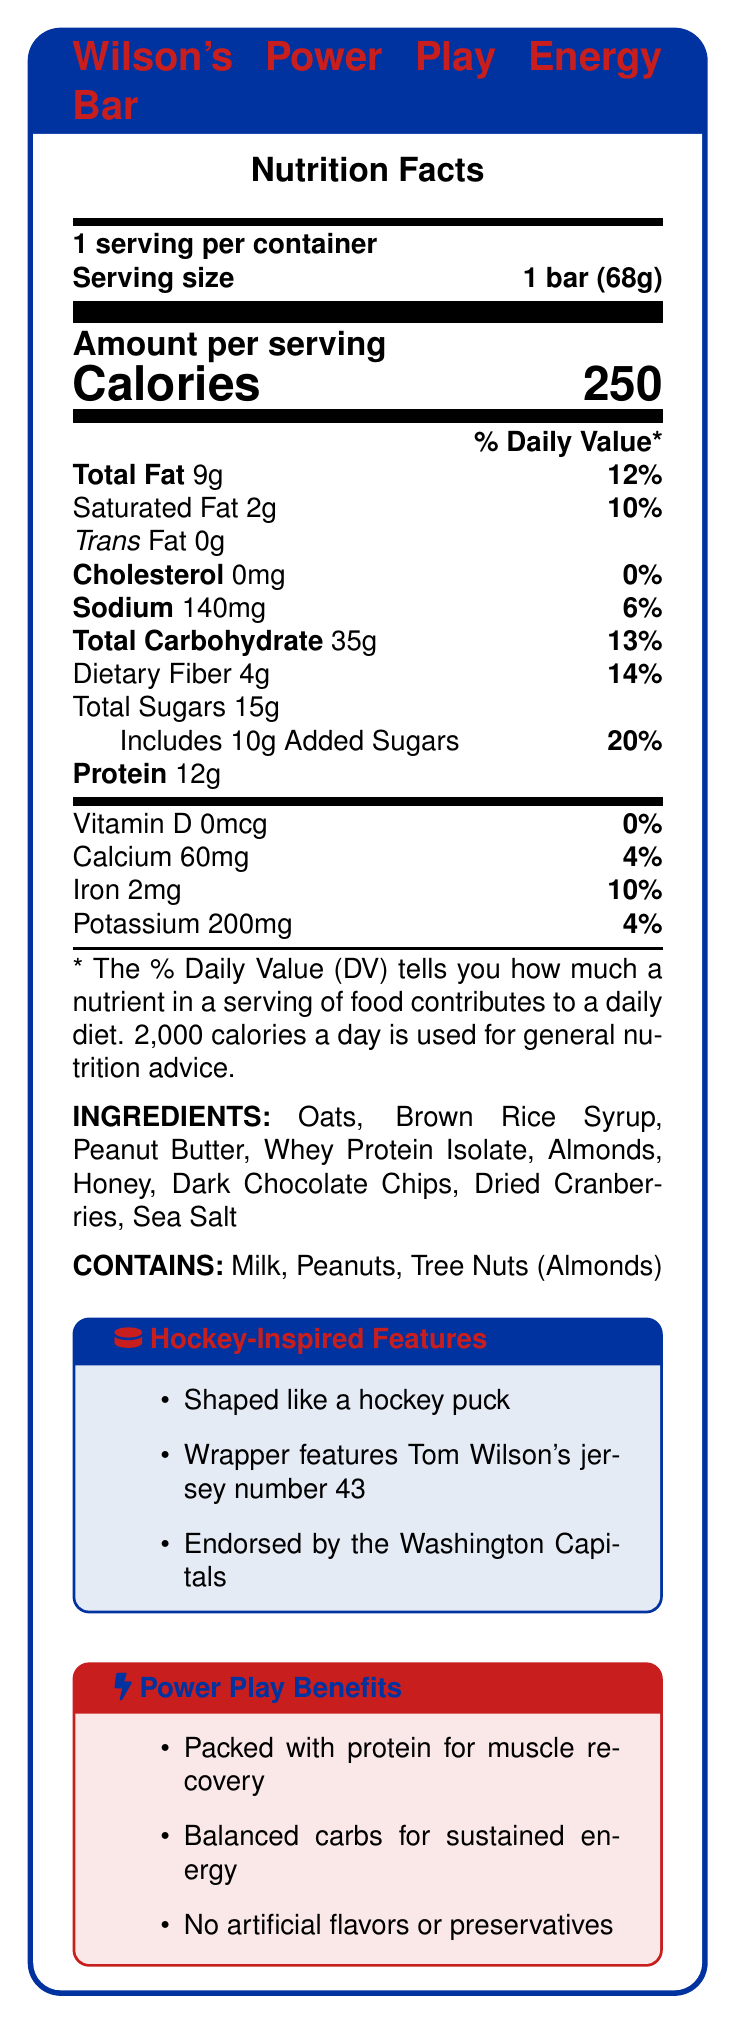What is the serving size of Wilson's Power Play Energy Bar? The document specifies that the serving size for Wilson's Power Play Energy Bar is 1 bar (68g).
Answer: 1 bar (68g) What is the amount of added sugars in the energy bar? According to the Nutrition Facts, the energy bar contains 10g of added sugars.
Answer: 10g How much protein does the bar contain? The document states that there is 12g of protein per serving in the energy bar.
Answer: 12g Which vitamin is completely absent in Wilson's Power Play Energy Bar? The label shows that there is 0mcg of Vitamin D, which means it is absent.
Answer: Vitamin D What are the main ingredients in Wilson's Power Play Energy Bar? The ingredients listed on the document are the main components of the energy bar.
Answer: Oats, Brown Rice Syrup, Peanut Butter, Whey Protein Isolate, Almonds, Honey, Dark Chocolate Chips, Dried Cranberries, Sea Salt How much is the daily value percentage for total carbohydrates? A. 10% B. 13% C. 20% D. 25% The daily value percentage for total carbohydrates is 13%, according to the document.
Answer: B What is the energy bar's unique shape inspired by? A. Hockey stick B. Puck C. Jersey D. Skate The document mentions that the energy bar is shaped like a hockey puck.
Answer: B Does Wilson's Power Play Energy Bar contain any artificial flavors or preservatives? The document claims that there are no artificial flavors or preservatives in the energy bar.
Answer: No Is Tom Wilson's jersey number included in the wrapper design? The document states that the wrapper features Tom Wilson's jersey number 43.
Answer: Yes Summarize the main idea of Wilson's Power Play Energy Bar nutrition label. The summary includes the main nutritional benefits and the unique hockey-themed aspects of the product, as detailed in the document.
Answer: The label provides nutritional information about Wilson's Power Play Energy Bar, emphasizing its protein content for muscle recovery, balanced carbohydrates for sustained energy, and lack of artificial flavors or preservatives. It also highlights unique hockey-inspired features, including a puck-shaped design and endorsement by Tom Wilson and the Washington Capitals. How much potassium is in one serving of the energy bar? The nutrition facts state that there are 200mg of potassium per serving.
Answer: 200mg Is there any dietary fiber in Wilson's Power Play Energy Bar? If so, how much? The document indicates that there is 4g of dietary fiber in each serving.
Answer: Yes, 4g. What allergens does the bar contain? The allergen information specifies that the bar contains milk, peanuts, and tree nuts (almonds).
Answer: Milk, Peanuts, Tree Nuts (Almonds) What is the percentage daily value of iron in the bar? The Nutrition Facts label notes that the bar provides 10% of the daily value for iron.
Answer: 10% Are there any endorsements mentioned on the energy bar's label? The document mentions that the energy bar is endorsed by the Washington Capitals.
Answer: Yes What team is associated with the endorsement of Wilson's Power Play Energy Bar? The document states that the energy bar is endorsed by the Washington Capitals.
Answer: Washington Capitals Can you determine the manufacturing location of Wilson's Power Play Energy Bar from the document? The document does not provide any details about the manufacturing location of the energy bar.
Answer: Not enough information 